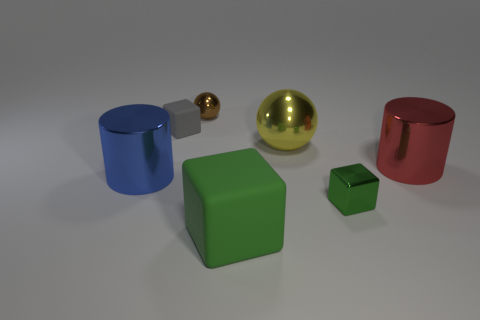Add 1 rubber cubes. How many objects exist? 8 Subtract all cubes. How many objects are left? 4 Add 1 tiny blue objects. How many tiny blue objects exist? 1 Subtract 0 blue cubes. How many objects are left? 7 Subtract all shiny objects. Subtract all large green rubber cubes. How many objects are left? 1 Add 1 yellow metallic spheres. How many yellow metallic spheres are left? 2 